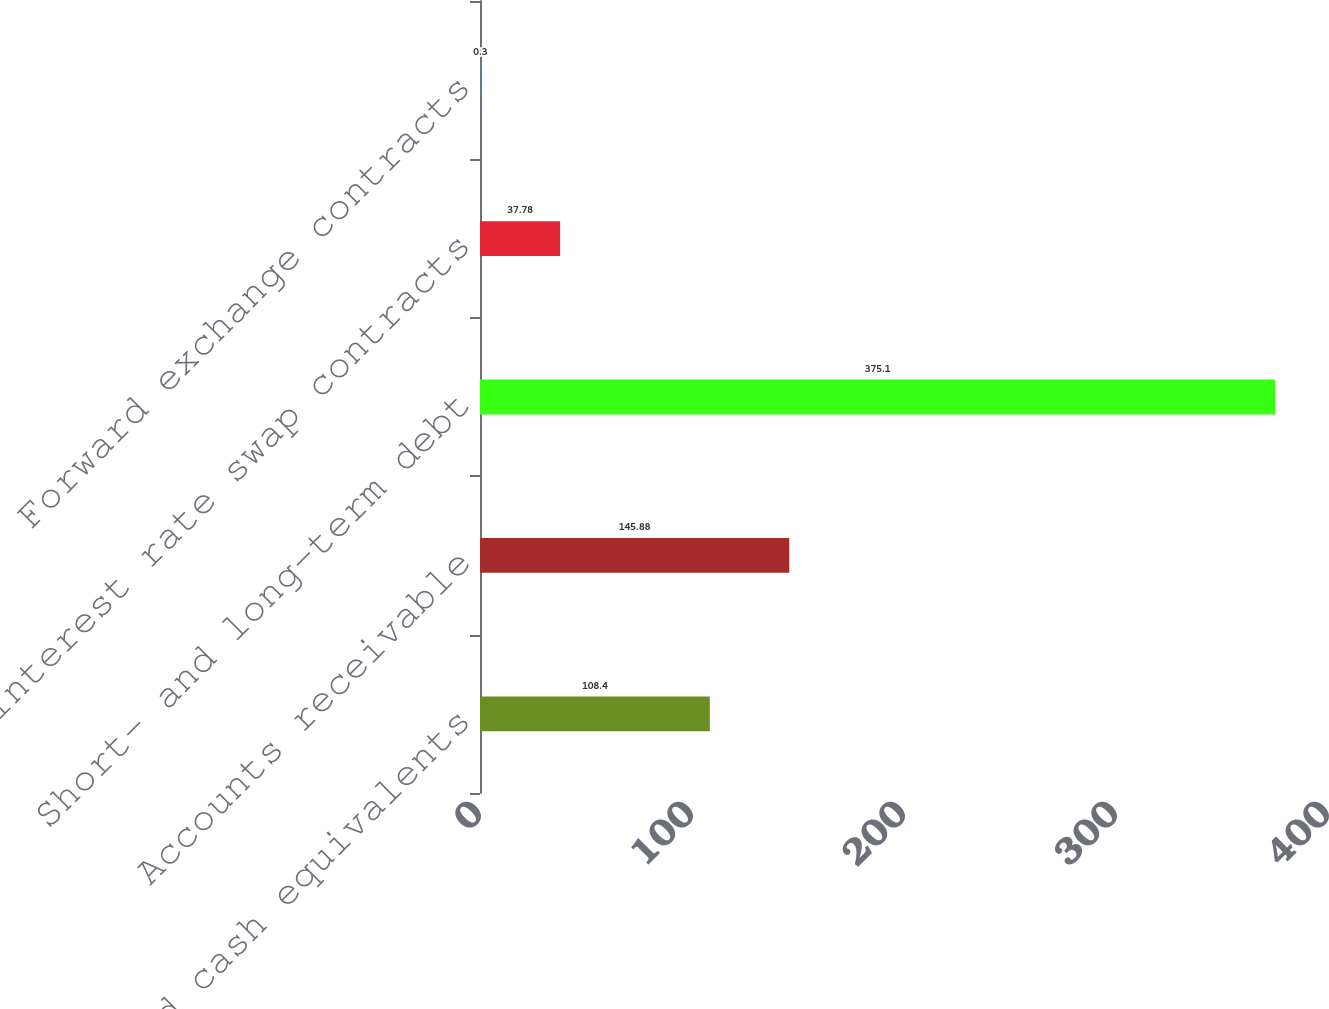Convert chart. <chart><loc_0><loc_0><loc_500><loc_500><bar_chart><fcel>Cash and cash equivalents<fcel>Accounts receivable<fcel>Short- and long-term debt<fcel>Interest rate swap contracts<fcel>Forward exchange contracts<nl><fcel>108.4<fcel>145.88<fcel>375.1<fcel>37.78<fcel>0.3<nl></chart> 